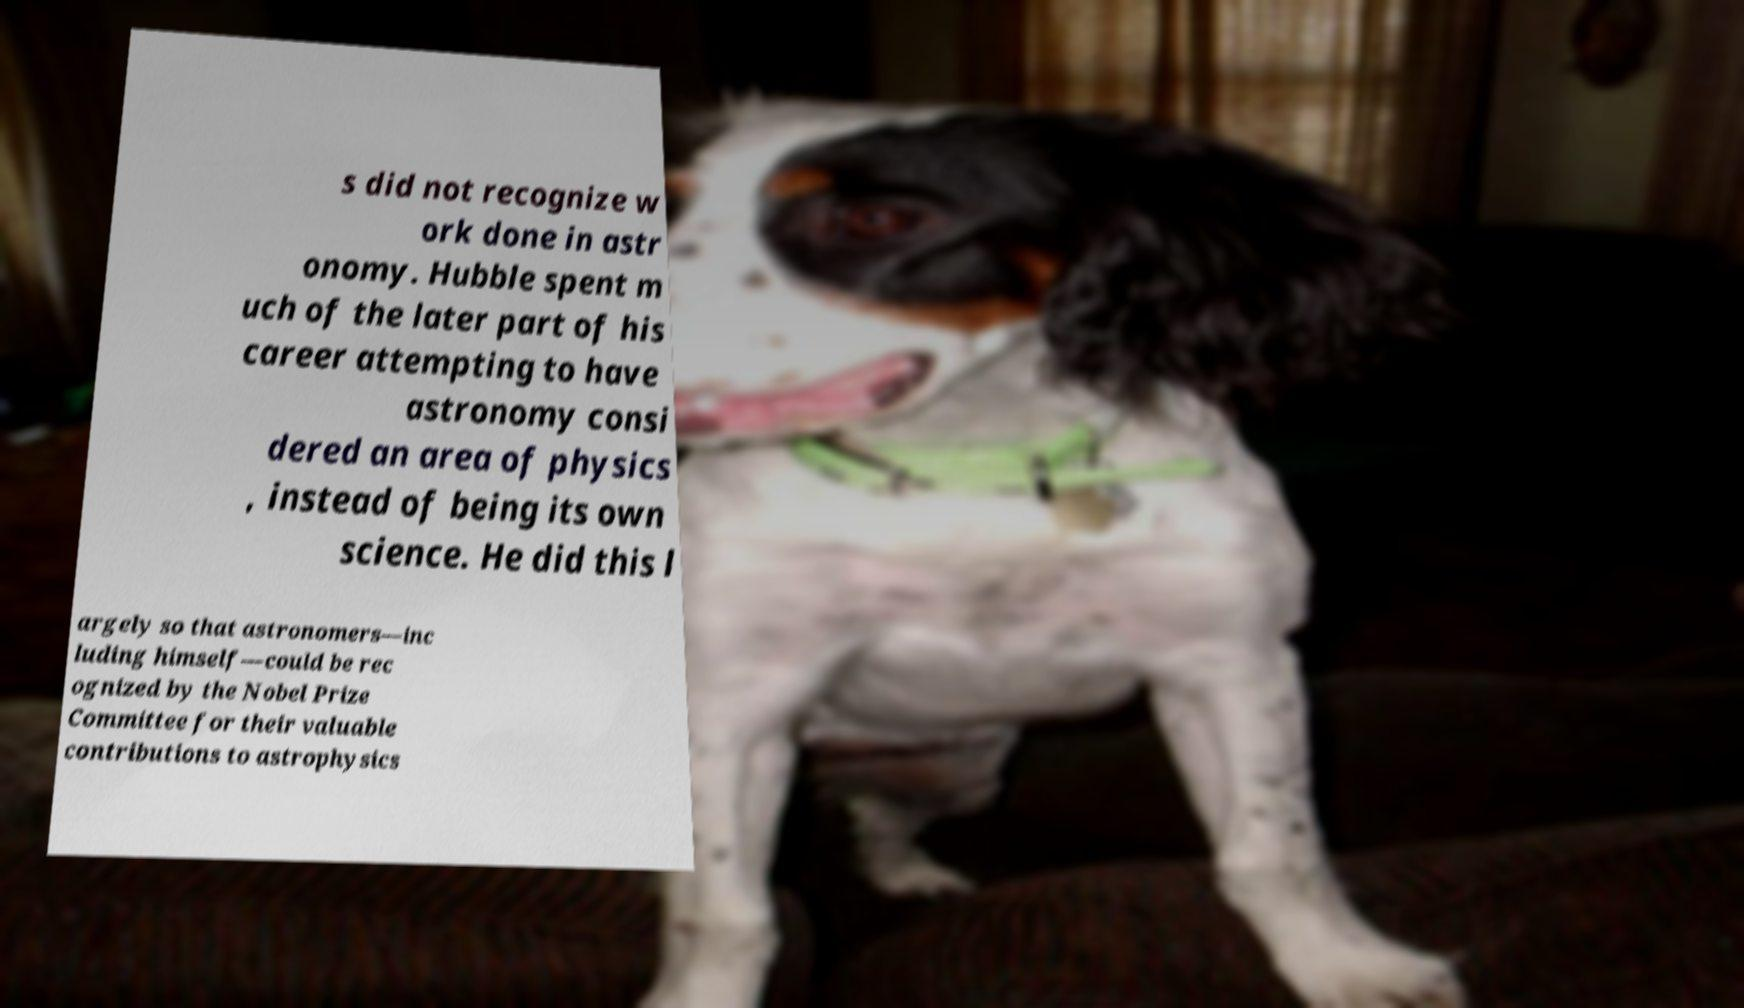Could you extract and type out the text from this image? s did not recognize w ork done in astr onomy. Hubble spent m uch of the later part of his career attempting to have astronomy consi dered an area of physics , instead of being its own science. He did this l argely so that astronomers—inc luding himself—could be rec ognized by the Nobel Prize Committee for their valuable contributions to astrophysics 